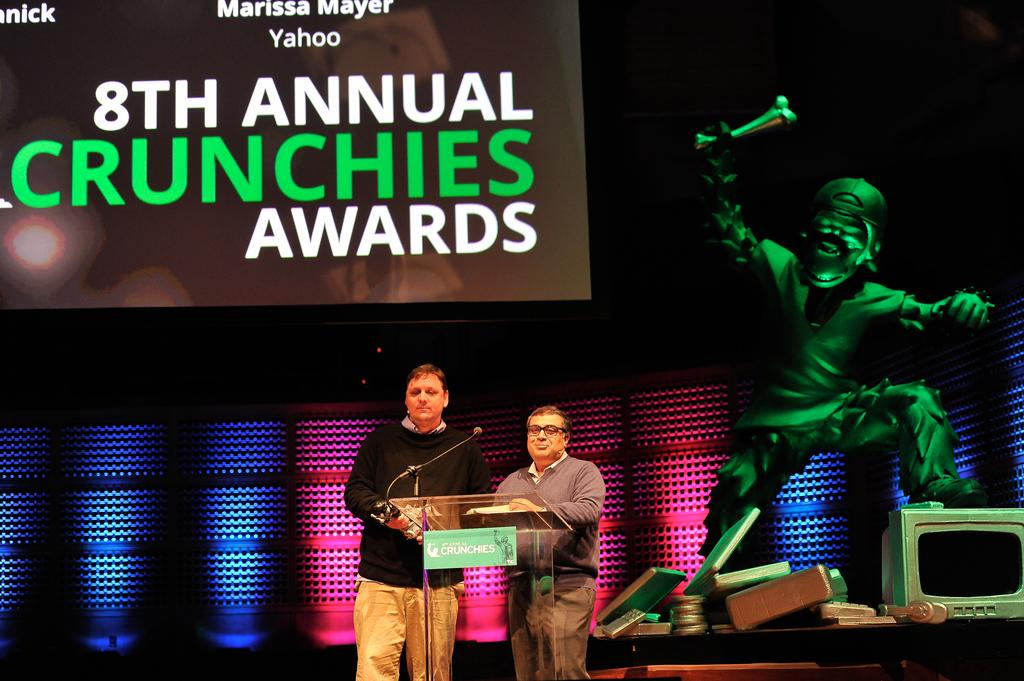<image>
Provide a brief description of the given image. Two people are on the stage at the 8th annual Crunchies Awards. 